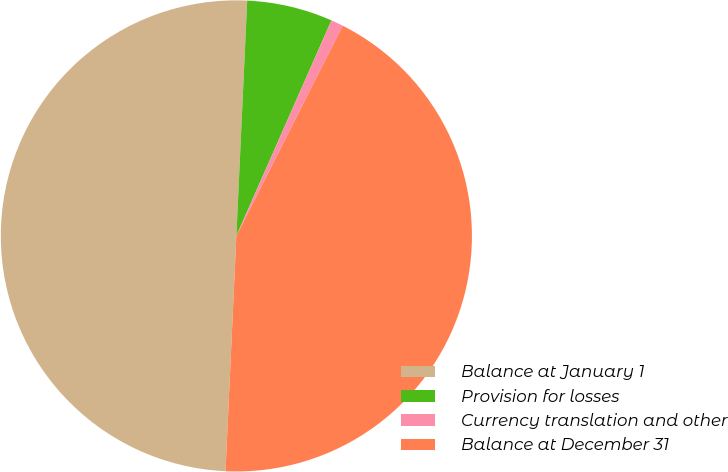<chart> <loc_0><loc_0><loc_500><loc_500><pie_chart><fcel>Balance at January 1<fcel>Provision for losses<fcel>Currency translation and other<fcel>Balance at December 31<nl><fcel>50.0%<fcel>5.88%<fcel>0.84%<fcel>43.28%<nl></chart> 